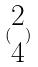Convert formula to latex. <formula><loc_0><loc_0><loc_500><loc_500>( \begin{matrix} 2 \\ 4 \end{matrix} )</formula> 